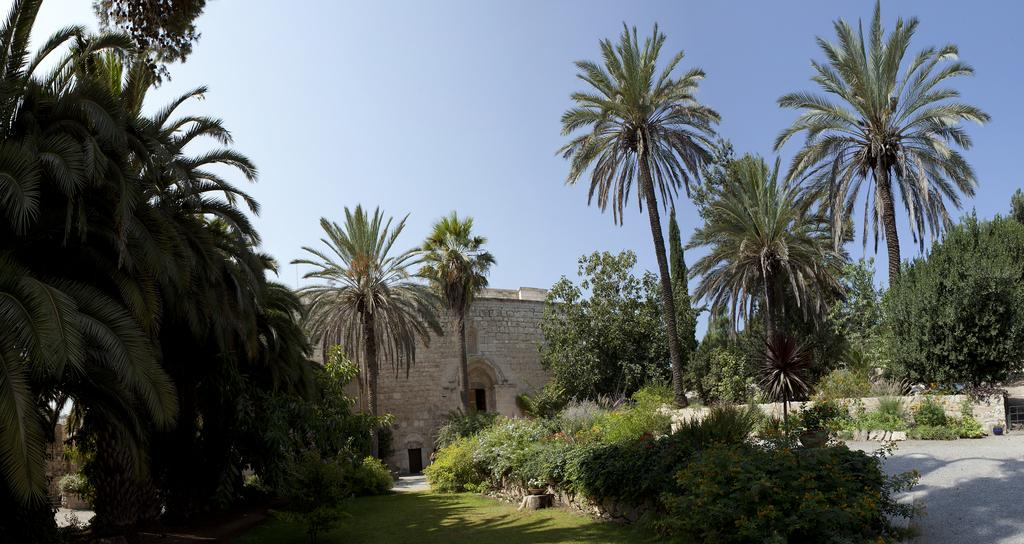What type of structure is visible in the image? There is a building in the image. What type of vegetation is present in front of the building? Trees, bushes, and grass are visible in front of the building. What is visible at the top of the image? The sky is visible at the top of the image. Where can the receipt for the purchase of the library be found in the image? There is no library or receipt present in the image. What type of shoes are visible on the grass in the image? There are no shoes visible in the image; only the building, trees, bushes, grass, and sky are present. 